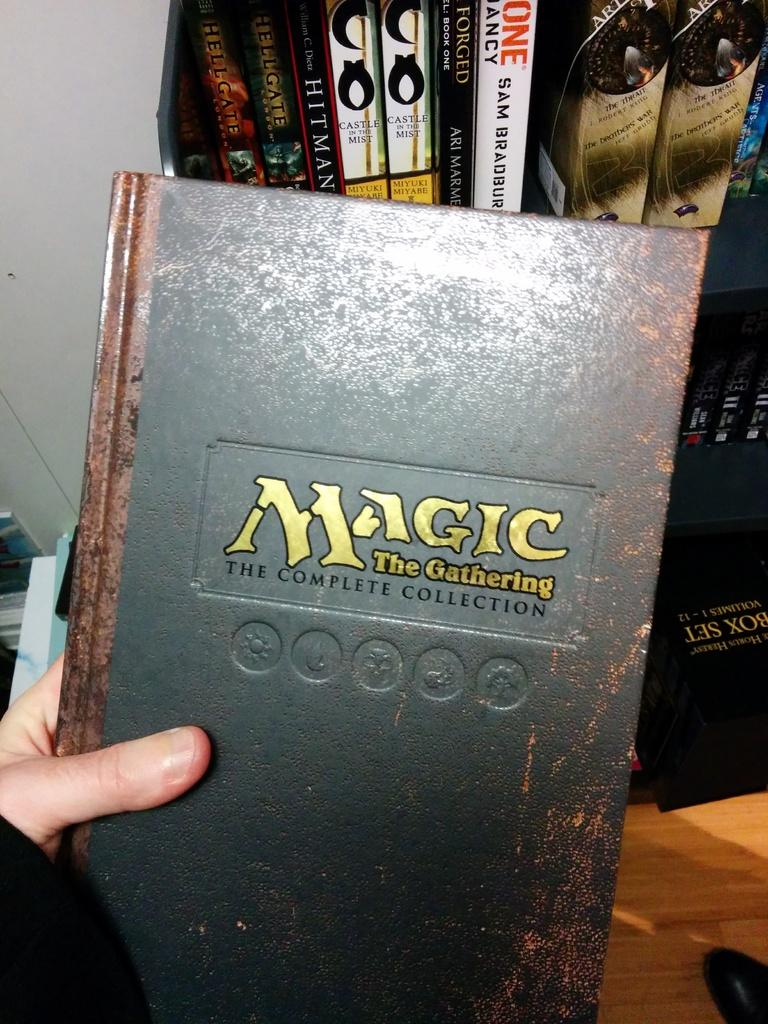<image>
Summarize the visual content of the image. A women holding a book called Magic The Gathering. 